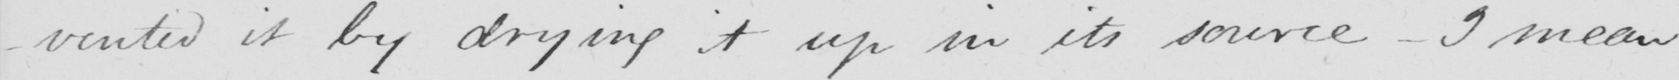What is written in this line of handwriting? -vented it by drying it up in its source  _  I mean 